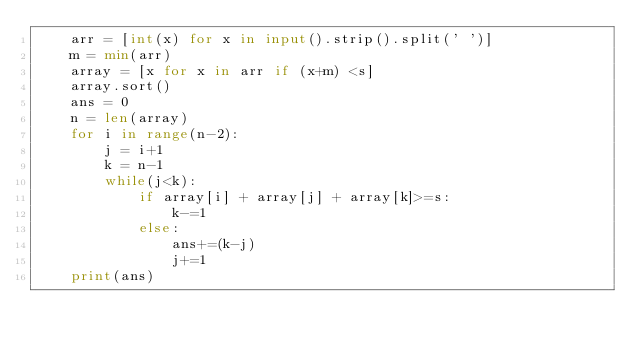Convert code to text. <code><loc_0><loc_0><loc_500><loc_500><_Python_>    arr = [int(x) for x in input().strip().split(' ')]
    m = min(arr)
    array = [x for x in arr if (x+m) <s]
    array.sort()
    ans = 0
    n = len(array)
    for i in range(n-2):
        j = i+1
        k = n-1
        while(j<k):
            if array[i] + array[j] + array[k]>=s:
                k-=1
            else:
                ans+=(k-j)
                j+=1
    print(ans)
</code> 